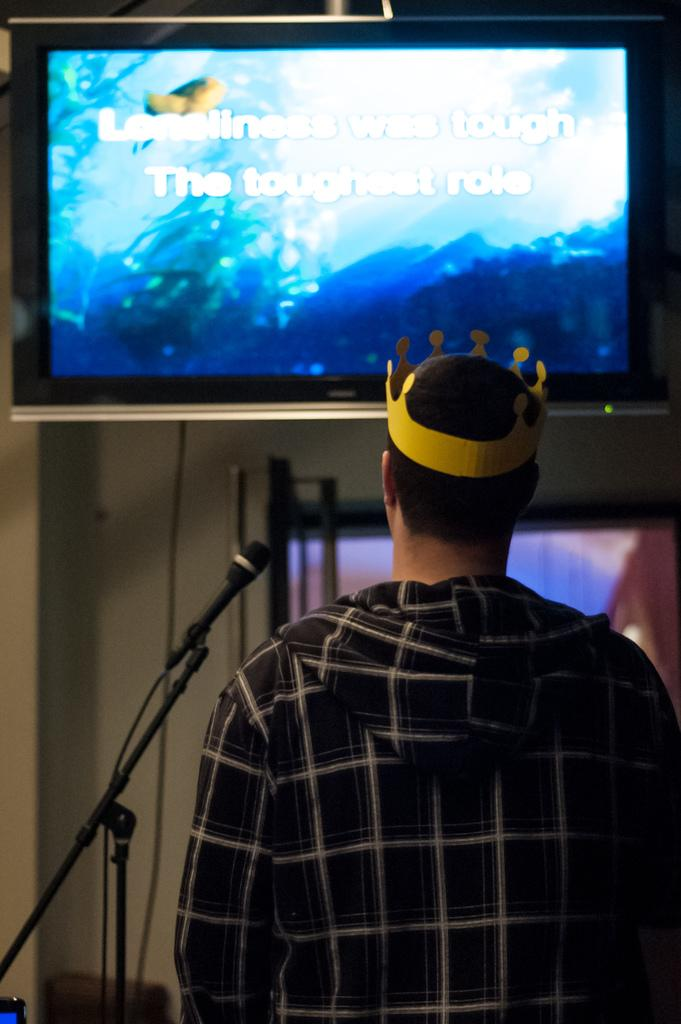What is the person in the image doing? The facts do not specify what the person is doing, but they are standing in the image. What color is the shirt the person is wearing? The person is wearing a black color shirt. What objects can be seen in the background of the image? There is a microphone and a screen in the background of the image. Is the person swimming in the image? No, there is no indication that the person is swimming in the image. The person is standing, and there is no water or swimming pool visible. 